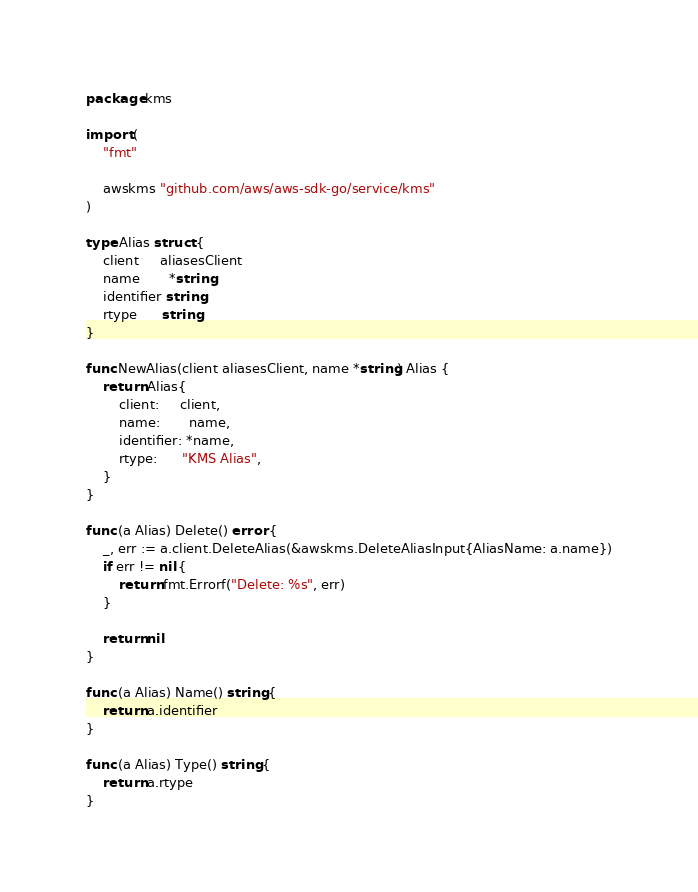<code> <loc_0><loc_0><loc_500><loc_500><_Go_>package kms

import (
	"fmt"

	awskms "github.com/aws/aws-sdk-go/service/kms"
)

type Alias struct {
	client     aliasesClient
	name       *string
	identifier string
	rtype      string
}

func NewAlias(client aliasesClient, name *string) Alias {
	return Alias{
		client:     client,
		name:       name,
		identifier: *name,
		rtype:      "KMS Alias",
	}
}

func (a Alias) Delete() error {
	_, err := a.client.DeleteAlias(&awskms.DeleteAliasInput{AliasName: a.name})
	if err != nil {
		return fmt.Errorf("Delete: %s", err)
	}

	return nil
}

func (a Alias) Name() string {
	return a.identifier
}

func (a Alias) Type() string {
	return a.rtype
}
</code> 